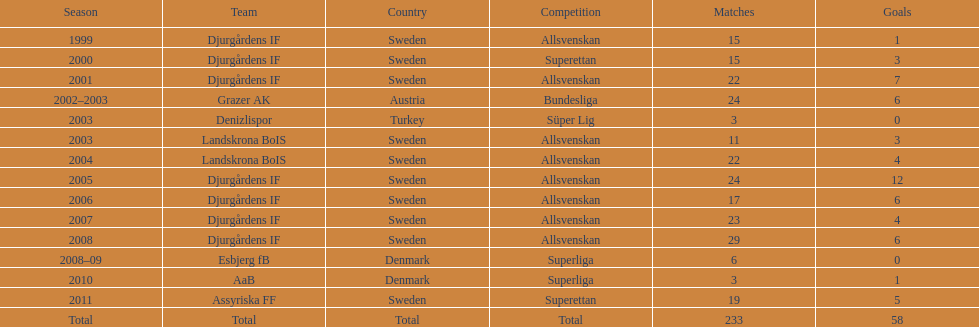How many teams had more than 20 games in the season? 6. 